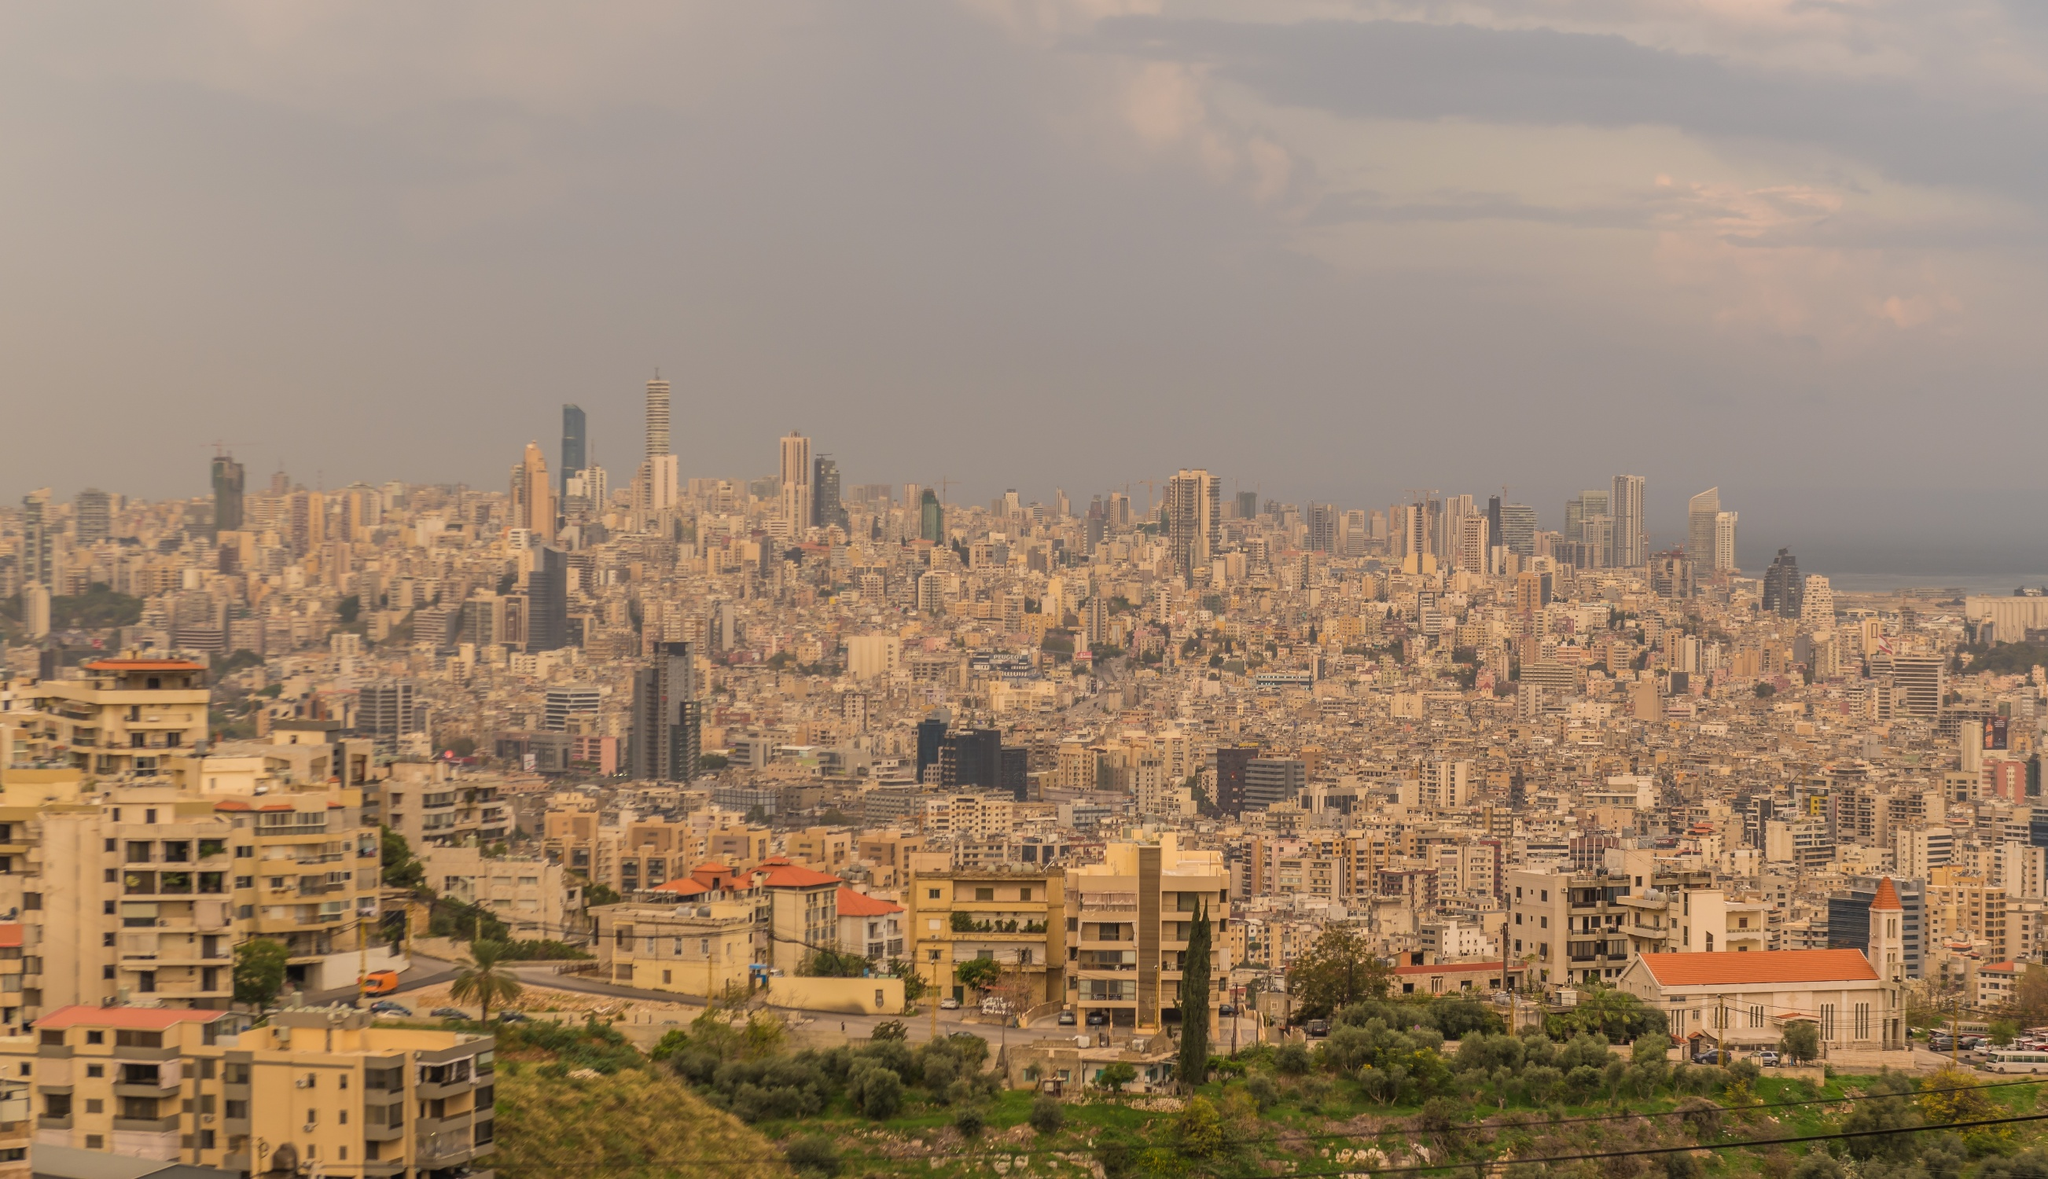What do you think is going on in this snapshot? The image captures the breathtaking view of Beirut, the capital city of Lebanon, from a high vantage point. The cityscape is densely populated with buildings of various heights and architectural styles, creating a mosaic of urban life. Dominating the skyline is the Sama Beirut tower, a skyscraper with a unique curved silhouette that stands out against its surroundings. The sky above is painted in a hazy orange hue, possibly a result of pollution or the setting sun casting its warm glow over the city. In the distance, the tranquil waters of the Mediterranean Sea provide a stark contrast to the bustling city, adding a serene touch to the overall scene. The image is a testament to the city's vibrant life and its blend of modernity and tradition. 